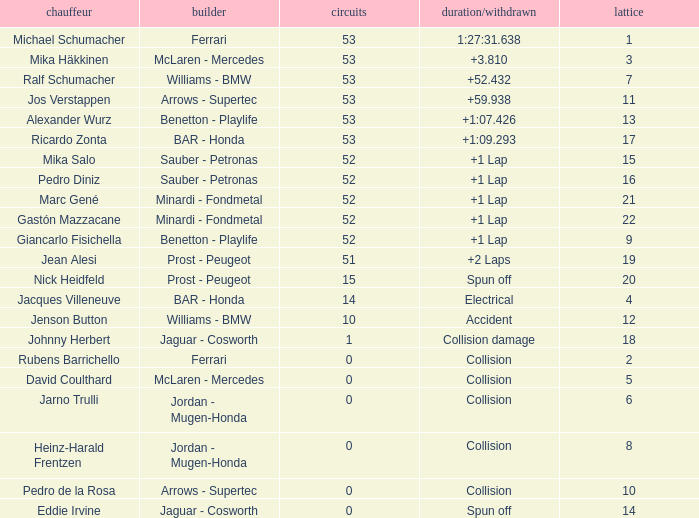What is the average Laps for a grid smaller than 17, and a Constructor of williams - bmw, driven by jenson button? 10.0. 